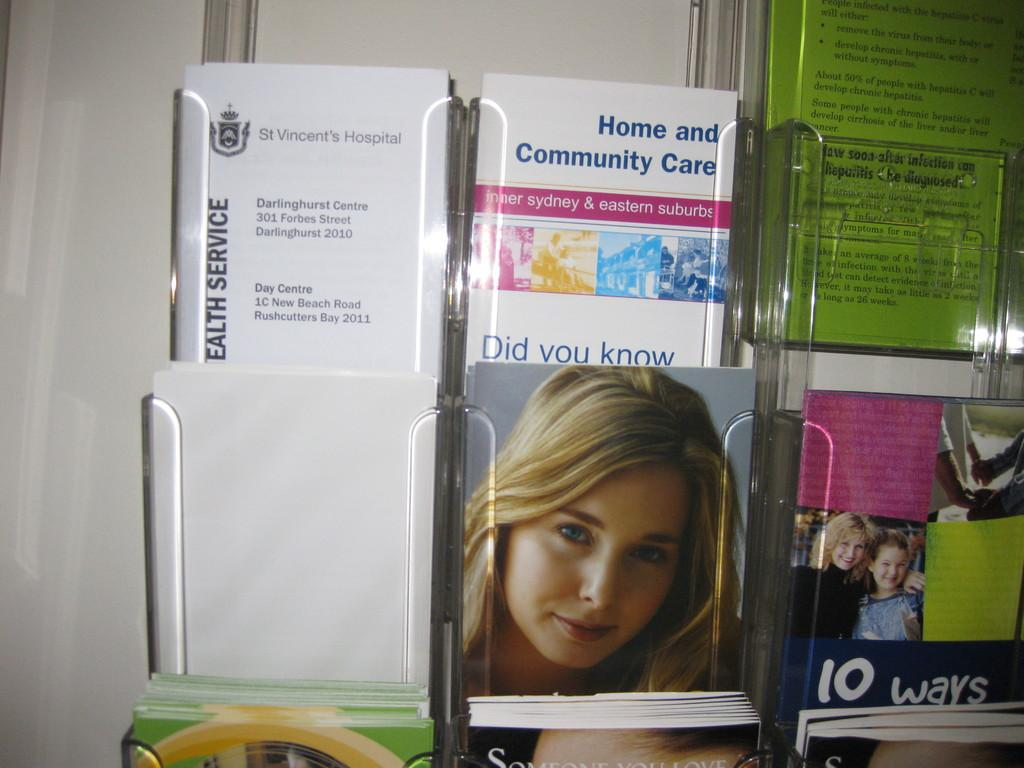What objects are present in the image? There are books in the image. What is the books resting on? The books are on a glass object. What can be seen on the book covers? The book covers have photos of people and writing. What type of cake is being served at the place shown in the image? There is no cake or place shown in the image; it features books on a glass object. What curve can be seen in the image? There is no curve present in the image; it features books on a glass object with photos of people and writing on their covers. 